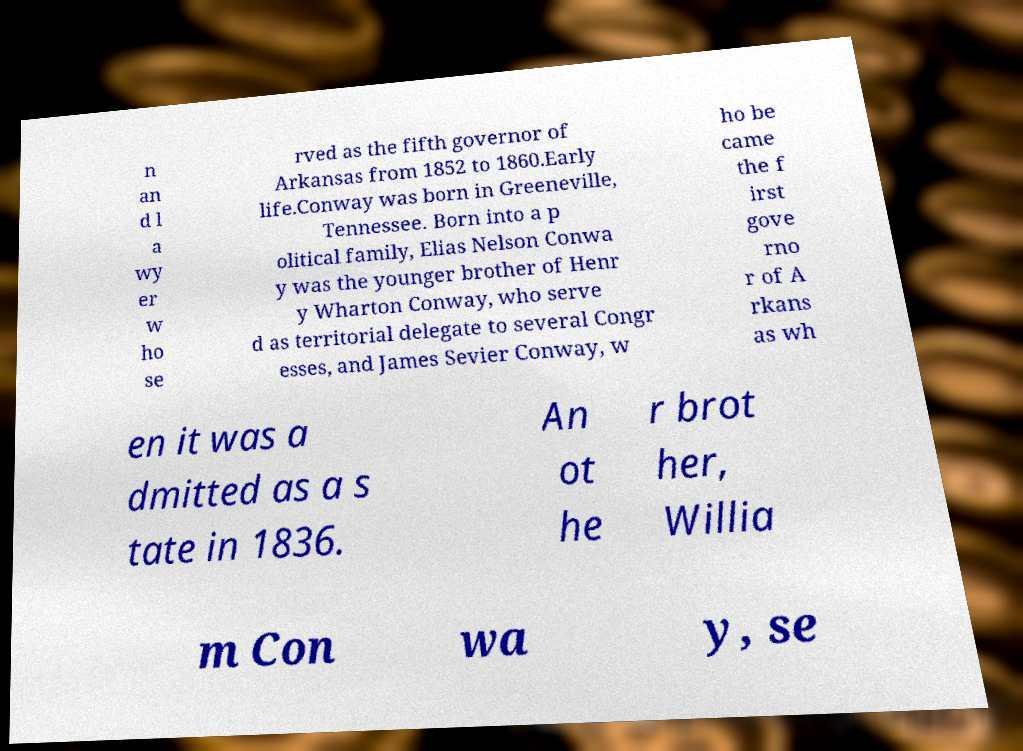Please read and relay the text visible in this image. What does it say? n an d l a wy er w ho se rved as the fifth governor of Arkansas from 1852 to 1860.Early life.Conway was born in Greeneville, Tennessee. Born into a p olitical family, Elias Nelson Conwa y was the younger brother of Henr y Wharton Conway, who serve d as territorial delegate to several Congr esses, and James Sevier Conway, w ho be came the f irst gove rno r of A rkans as wh en it was a dmitted as a s tate in 1836. An ot he r brot her, Willia m Con wa y, se 